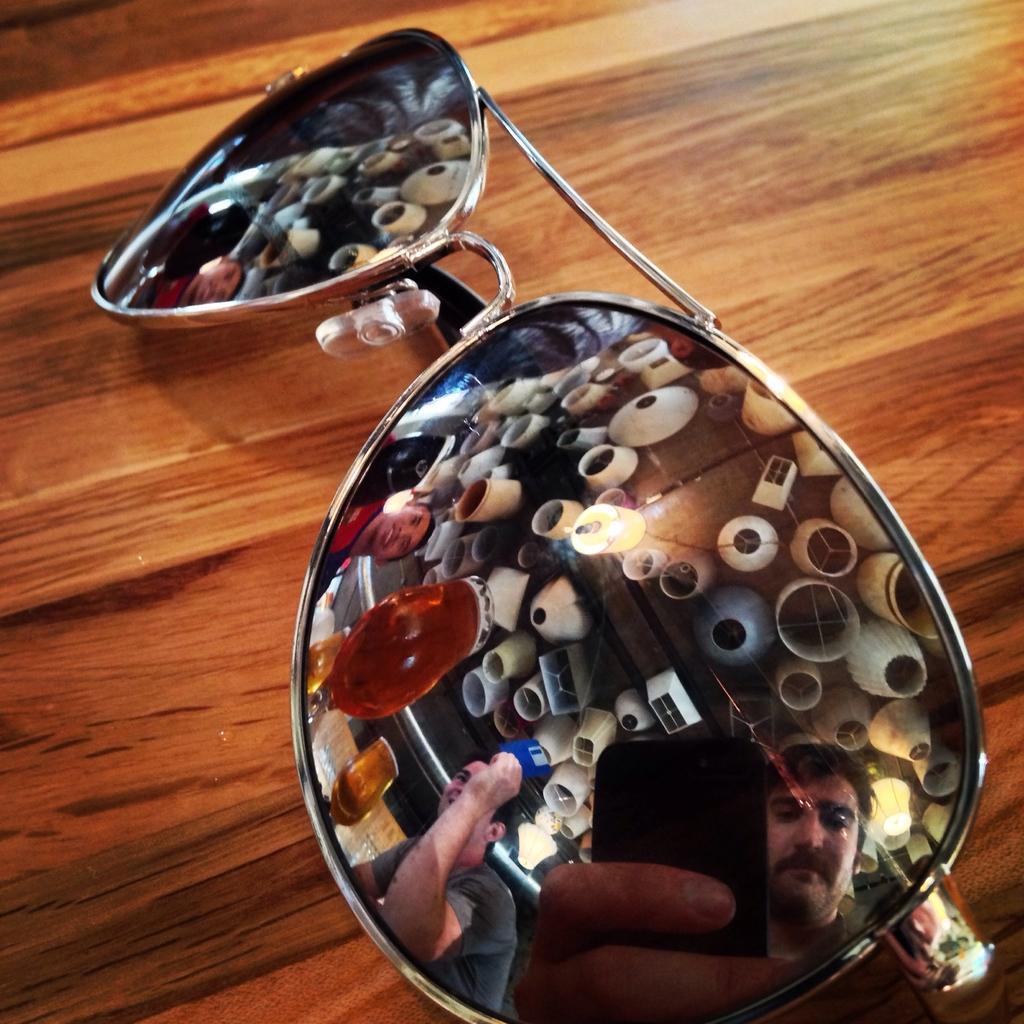In one or two sentences, can you explain what this image depicts? In this image we could see goggles on the table, and on the goggles we could see a reflection of persons and glasses and lights. 